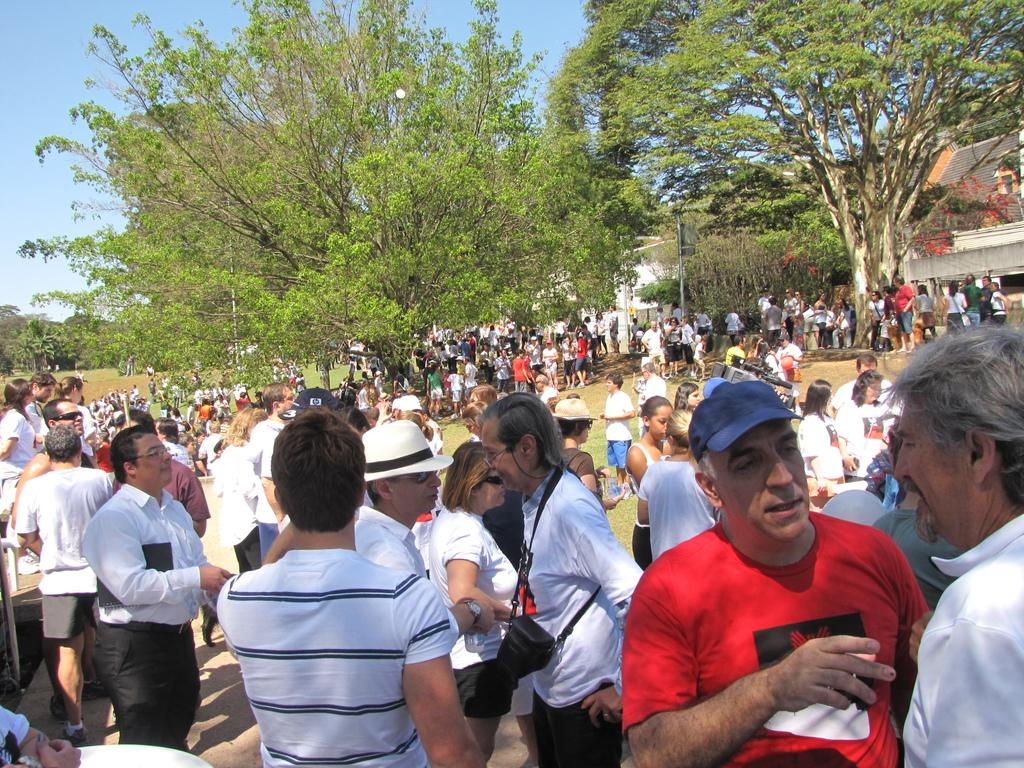What are the people in the image doing? The people in the image are standing on the ground. What can be seen in the background of the image? There are trees, buildings, and the sky visible in the background of the image. What type of cracker is being used as a canvas by the insect in the image? There is no cracker or insect present in the image. 